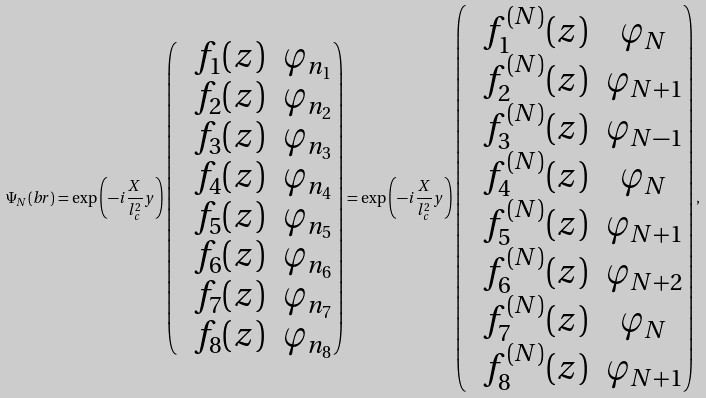Convert formula to latex. <formula><loc_0><loc_0><loc_500><loc_500>\Psi _ { N } ( \mathit b { r } ) = \exp \left ( - i \frac { X } { l _ { c } ^ { 2 } } y \right ) \begin{pmatrix} & f _ { 1 } ( z ) & \varphi _ { n _ { 1 } } \\ & f _ { 2 } ( z ) & \varphi _ { n _ { 2 } } \\ & f _ { 3 } ( z ) & \varphi _ { n _ { 3 } } \\ & f _ { 4 } ( z ) & \varphi _ { n _ { 4 } } \\ & f _ { 5 } ( z ) & \varphi _ { n _ { 5 } } \\ & f _ { 6 } ( z ) & \varphi _ { n _ { 6 } } \\ & f _ { 7 } ( z ) & \varphi _ { n _ { 7 } } \\ & f _ { 8 } ( z ) & \varphi _ { n _ { 8 } } \end{pmatrix} = \exp \left ( - i \frac { X } { l _ { c } ^ { 2 } } y \right ) \begin{pmatrix} & f _ { 1 } ^ { ( N ) } ( z ) & \varphi _ { N } \\ & f _ { 2 } ^ { ( N ) } ( z ) & \varphi _ { N + 1 } \\ & f _ { 3 } ^ { ( N ) } ( z ) & \varphi _ { N - 1 } \\ & f _ { 4 } ^ { ( N ) } ( z ) & \varphi _ { N } \\ & f _ { 5 } ^ { ( N ) } ( z ) & \varphi _ { N + 1 } \\ & f _ { 6 } ^ { ( N ) } ( z ) & \varphi _ { N + 2 } \\ & f _ { 7 } ^ { ( N ) } ( z ) & \varphi _ { N } \\ & f _ { 8 } ^ { ( N ) } ( z ) & \varphi _ { N + 1 } \end{pmatrix} ,</formula> 